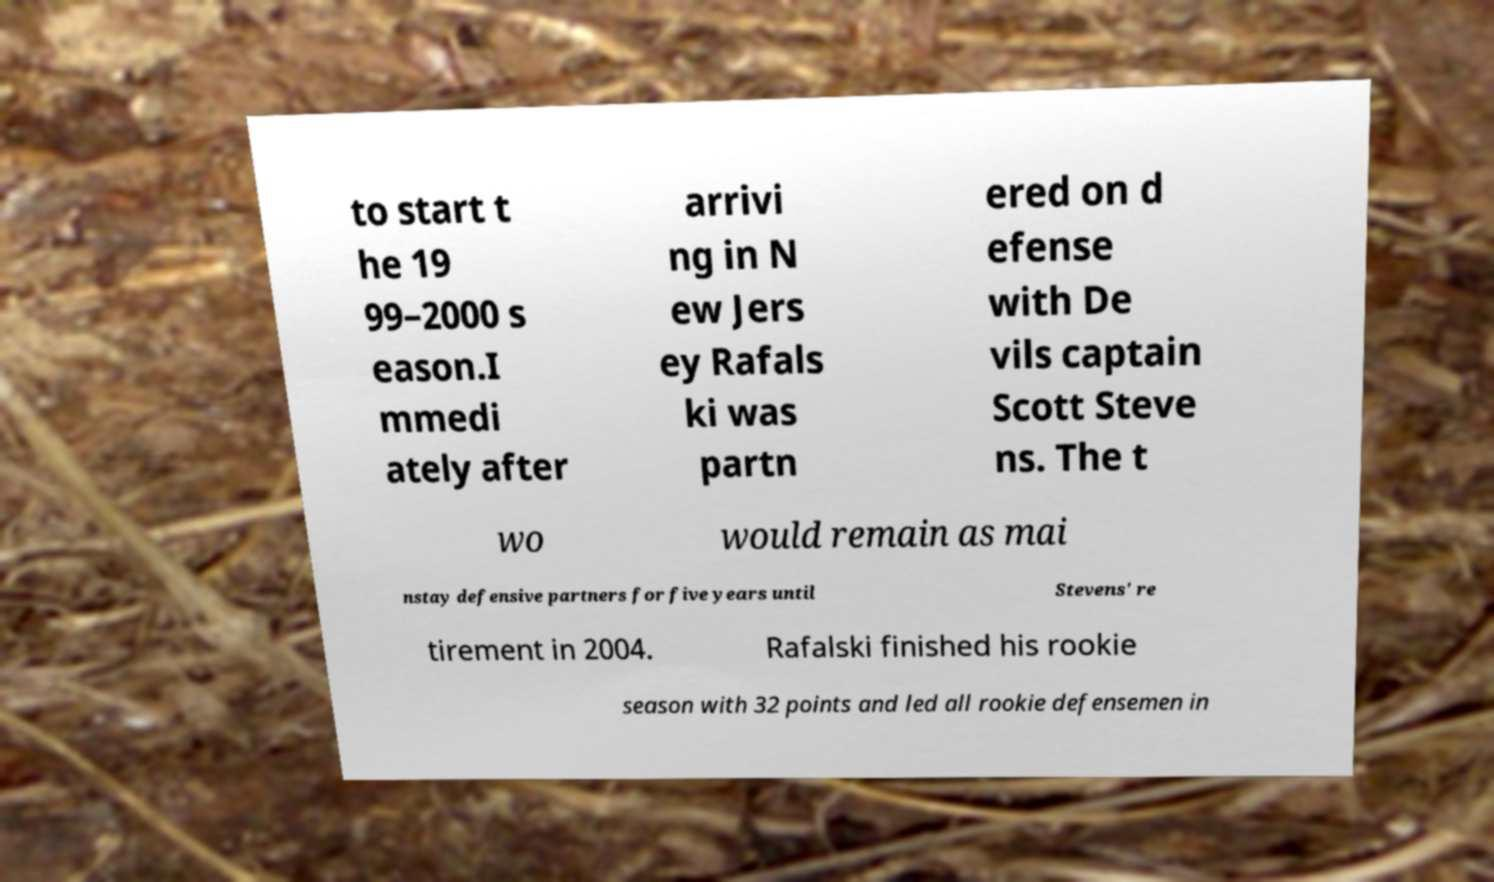I need the written content from this picture converted into text. Can you do that? to start t he 19 99–2000 s eason.I mmedi ately after arrivi ng in N ew Jers ey Rafals ki was partn ered on d efense with De vils captain Scott Steve ns. The t wo would remain as mai nstay defensive partners for five years until Stevens' re tirement in 2004. Rafalski finished his rookie season with 32 points and led all rookie defensemen in 